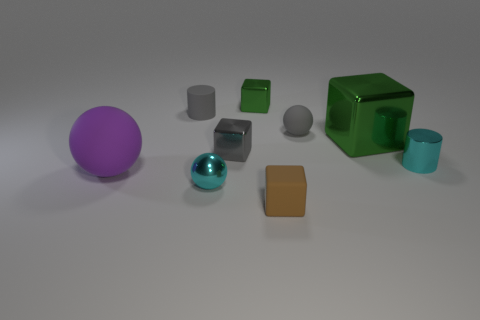Is there any other thing that is the same shape as the big green metal object?
Ensure brevity in your answer.  Yes. Is there a object that is behind the cylinder to the left of the small cyan cylinder?
Ensure brevity in your answer.  Yes. Is the number of green metal cubes that are in front of the big purple object less than the number of large green blocks that are on the right side of the small cyan cylinder?
Keep it short and to the point. No. How big is the matte object in front of the big thing that is on the left side of the tiny matte thing in front of the tiny cyan sphere?
Give a very brief answer. Small. There is a ball that is behind the purple matte sphere; is its size the same as the brown block?
Provide a short and direct response. Yes. How many other things are the same material as the big purple ball?
Provide a succinct answer. 3. Are there more large cyan matte objects than large green metallic cubes?
Make the answer very short. No. What material is the cyan object on the right side of the metal cube that is behind the small cylinder behind the big block?
Your response must be concise. Metal. Does the tiny shiny sphere have the same color as the small matte cylinder?
Keep it short and to the point. No. Are there any rubber blocks that have the same color as the big rubber thing?
Make the answer very short. No. 